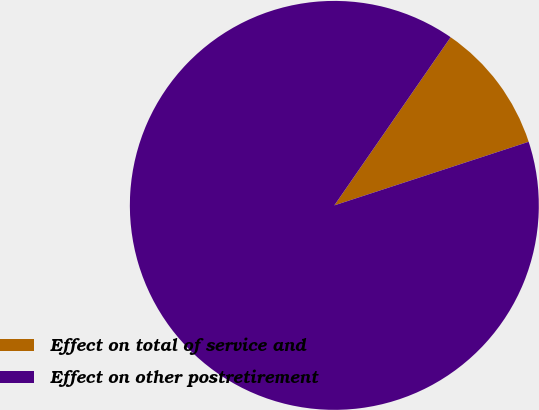<chart> <loc_0><loc_0><loc_500><loc_500><pie_chart><fcel>Effect on total of service and<fcel>Effect on other postretirement<nl><fcel>10.34%<fcel>89.66%<nl></chart> 